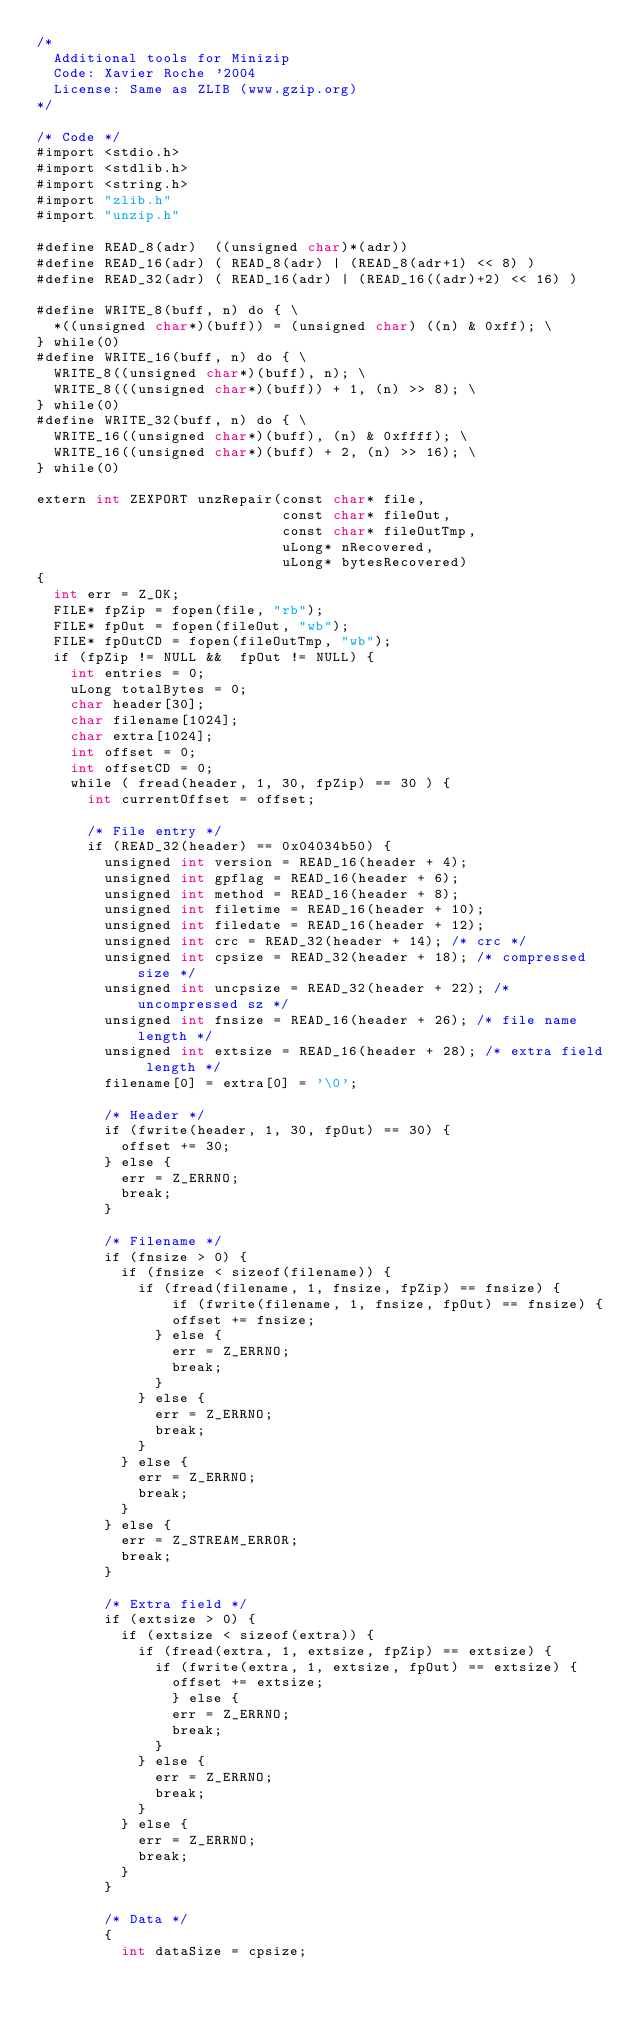Convert code to text. <code><loc_0><loc_0><loc_500><loc_500><_ObjectiveC_>/*
  Additional tools for Minizip
  Code: Xavier Roche '2004
  License: Same as ZLIB (www.gzip.org)
*/

/* Code */
#import <stdio.h>
#import <stdlib.h>
#import <string.h>
#import "zlib.h"
#import "unzip.h"

#define READ_8(adr)  ((unsigned char)*(adr))
#define READ_16(adr) ( READ_8(adr) | (READ_8(adr+1) << 8) )
#define READ_32(adr) ( READ_16(adr) | (READ_16((adr)+2) << 16) )

#define WRITE_8(buff, n) do { \
  *((unsigned char*)(buff)) = (unsigned char) ((n) & 0xff); \
} while(0)
#define WRITE_16(buff, n) do { \
  WRITE_8((unsigned char*)(buff), n); \
  WRITE_8(((unsigned char*)(buff)) + 1, (n) >> 8); \
} while(0)
#define WRITE_32(buff, n) do { \
  WRITE_16((unsigned char*)(buff), (n) & 0xffff); \
  WRITE_16((unsigned char*)(buff) + 2, (n) >> 16); \
} while(0)

extern int ZEXPORT unzRepair(const char* file,
                             const char* fileOut,
                             const char* fileOutTmp,
                             uLong* nRecovered,
                             uLong* bytesRecovered)
{
  int err = Z_OK;
  FILE* fpZip = fopen(file, "rb");
  FILE* fpOut = fopen(fileOut, "wb");
  FILE* fpOutCD = fopen(fileOutTmp, "wb");
  if (fpZip != NULL &&  fpOut != NULL) {
    int entries = 0;
    uLong totalBytes = 0;
    char header[30];
    char filename[1024];
    char extra[1024];
    int offset = 0;
    int offsetCD = 0;
    while ( fread(header, 1, 30, fpZip) == 30 ) {
      int currentOffset = offset;

      /* File entry */
      if (READ_32(header) == 0x04034b50) {
        unsigned int version = READ_16(header + 4);
        unsigned int gpflag = READ_16(header + 6);
        unsigned int method = READ_16(header + 8);
        unsigned int filetime = READ_16(header + 10);
        unsigned int filedate = READ_16(header + 12);
        unsigned int crc = READ_32(header + 14); /* crc */
        unsigned int cpsize = READ_32(header + 18); /* compressed size */
        unsigned int uncpsize = READ_32(header + 22); /* uncompressed sz */
        unsigned int fnsize = READ_16(header + 26); /* file name length */
        unsigned int extsize = READ_16(header + 28); /* extra field length */
        filename[0] = extra[0] = '\0';

        /* Header */
        if (fwrite(header, 1, 30, fpOut) == 30) {
          offset += 30;
        } else {
          err = Z_ERRNO;
          break;
        }

        /* Filename */
        if (fnsize > 0) {
          if (fnsize < sizeof(filename)) {
            if (fread(filename, 1, fnsize, fpZip) == fnsize) {
                if (fwrite(filename, 1, fnsize, fpOut) == fnsize) {
                offset += fnsize;
              } else {
                err = Z_ERRNO;
                break;
              }
            } else {
              err = Z_ERRNO;
              break;
            }
          } else {
            err = Z_ERRNO;
            break;
          }
        } else {
          err = Z_STREAM_ERROR;
          break;
        }

        /* Extra field */
        if (extsize > 0) {
          if (extsize < sizeof(extra)) {
            if (fread(extra, 1, extsize, fpZip) == extsize) {
              if (fwrite(extra, 1, extsize, fpOut) == extsize) {
                offset += extsize;
                } else {
                err = Z_ERRNO;
                break;
              }
            } else {
              err = Z_ERRNO;
              break;
            }
          } else {
            err = Z_ERRNO;
            break;
          }
        }

        /* Data */
        {
          int dataSize = cpsize;</code> 